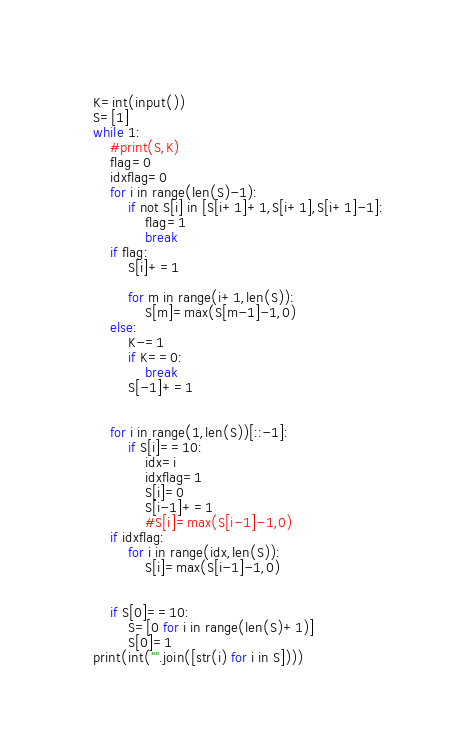<code> <loc_0><loc_0><loc_500><loc_500><_Python_>K=int(input())
S=[1]
while 1:
    #print(S,K)
    flag=0
    idxflag=0
    for i in range(len(S)-1):
        if not S[i] in [S[i+1]+1,S[i+1],S[i+1]-1]:
            flag=1
            break
    if flag:
        S[i]+=1

        for m in range(i+1,len(S)):
            S[m]=max(S[m-1]-1,0)
    else:
        K-=1
        if K==0:
            break
        S[-1]+=1


    for i in range(1,len(S))[::-1]:
        if S[i]==10:
            idx=i
            idxflag=1
            S[i]=0
            S[i-1]+=1
            #S[i]=max(S[i-1]-1,0)
    if idxflag:
        for i in range(idx,len(S)):
            S[i]=max(S[i-1]-1,0)


    if S[0]==10:
        S=[0 for i in range(len(S)+1)]
        S[0]=1
print(int("".join([str(i) for i in S])))
</code> 